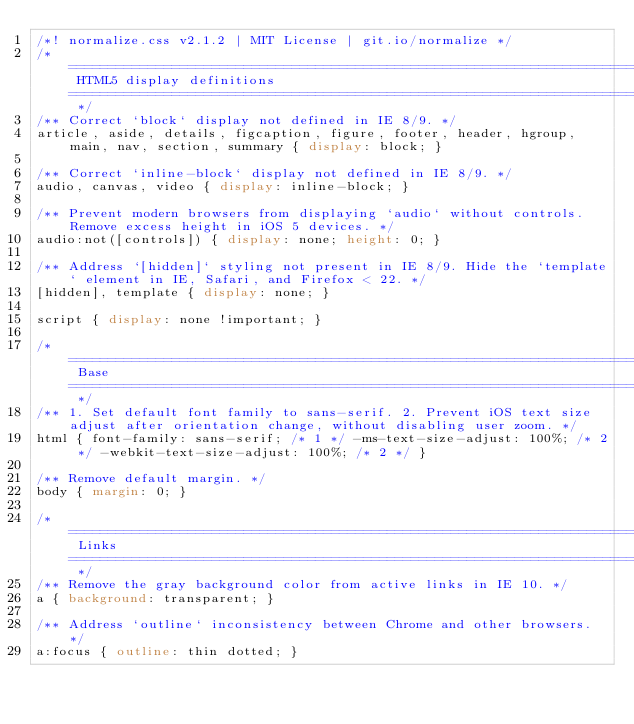<code> <loc_0><loc_0><loc_500><loc_500><_CSS_>/*! normalize.css v2.1.2 | MIT License | git.io/normalize */
/* ========================================================================== HTML5 display definitions ========================================================================== */
/** Correct `block` display not defined in IE 8/9. */
article, aside, details, figcaption, figure, footer, header, hgroup, main, nav, section, summary { display: block; }

/** Correct `inline-block` display not defined in IE 8/9. */
audio, canvas, video { display: inline-block; }

/** Prevent modern browsers from displaying `audio` without controls. Remove excess height in iOS 5 devices. */
audio:not([controls]) { display: none; height: 0; }

/** Address `[hidden]` styling not present in IE 8/9. Hide the `template` element in IE, Safari, and Firefox < 22. */
[hidden], template { display: none; }

script { display: none !important; }

/* ========================================================================== Base ========================================================================== */
/** 1. Set default font family to sans-serif. 2. Prevent iOS text size adjust after orientation change, without disabling user zoom. */
html { font-family: sans-serif; /* 1 */ -ms-text-size-adjust: 100%; /* 2 */ -webkit-text-size-adjust: 100%; /* 2 */ }

/** Remove default margin. */
body { margin: 0; }

/* ========================================================================== Links ========================================================================== */
/** Remove the gray background color from active links in IE 10. */
a { background: transparent; }

/** Address `outline` inconsistency between Chrome and other browsers. */
a:focus { outline: thin dotted; }
</code> 